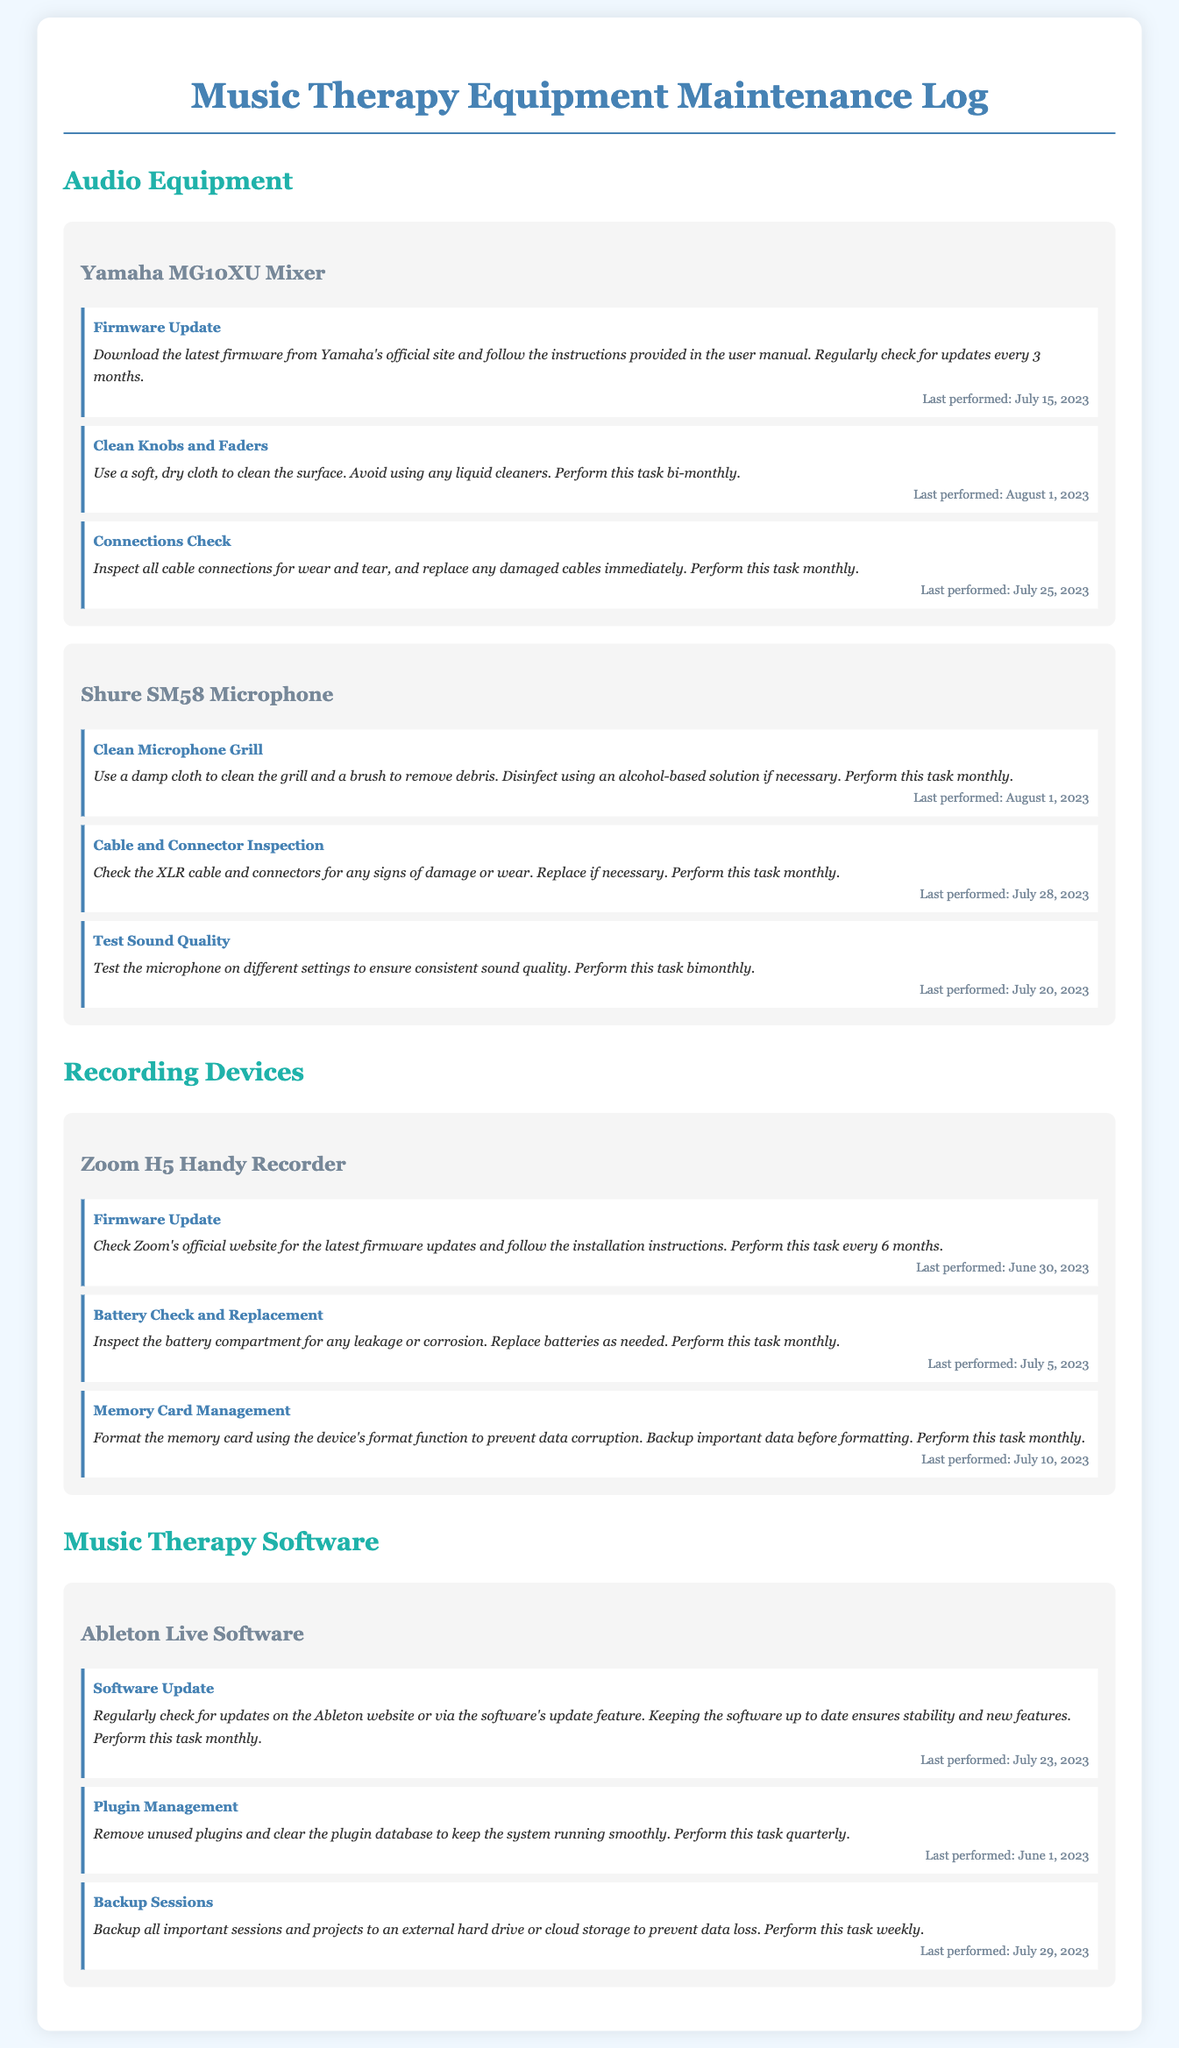what is the last performed date for the Yamaha MG10XU mixer firmware update? The last performed date for the firmware update on the Yamaha MG10XU mixer is mentioned in the document.
Answer: July 15, 2023 how often should the connections check be performed for the Yamaha MG10XU mixer? The document specifies the frequency of this task in relation to the Yamaha MG10XU mixer.
Answer: Monthly what is the main task performed monthly for the Shure SM58 microphone? The document details the tasks for the Shure SM58 microphone, including their frequencies.
Answer: Clean Microphone Grill what firmware update frequency is recommended for the Zoom H5 Handy Recorder? The document states how often the firmware update should occur, specifically for the Zoom H5 Handy Recorder.
Answer: Every 6 months which software requires a backup of sessions weekly? The document lists specific tasks for each software, including their frequencies.
Answer: Ableton Live Software what was the last performed date for the plugin management task in Ableton Live Software? The date for the last performed task is detailed in the document regarding plugin management for Ableton Live Software.
Answer: June 1, 2023 how often should the battery check and replacement be performed for the Zoom H5 Handy Recorder? The document indicates the frequency for this specific task for the Zoom H5 Handy Recorder.
Answer: Monthly how many tasks are listed for the Shure SM58 microphone? The document provides detailed task counts for each piece of equipment, including the Shure SM58 microphone.
Answer: Three 